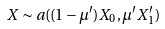Convert formula to latex. <formula><loc_0><loc_0><loc_500><loc_500>X \sim a ( ( 1 - \mu ^ { \prime } ) X _ { 0 } , \mu ^ { \prime } X ^ { \prime } _ { 1 } )</formula> 